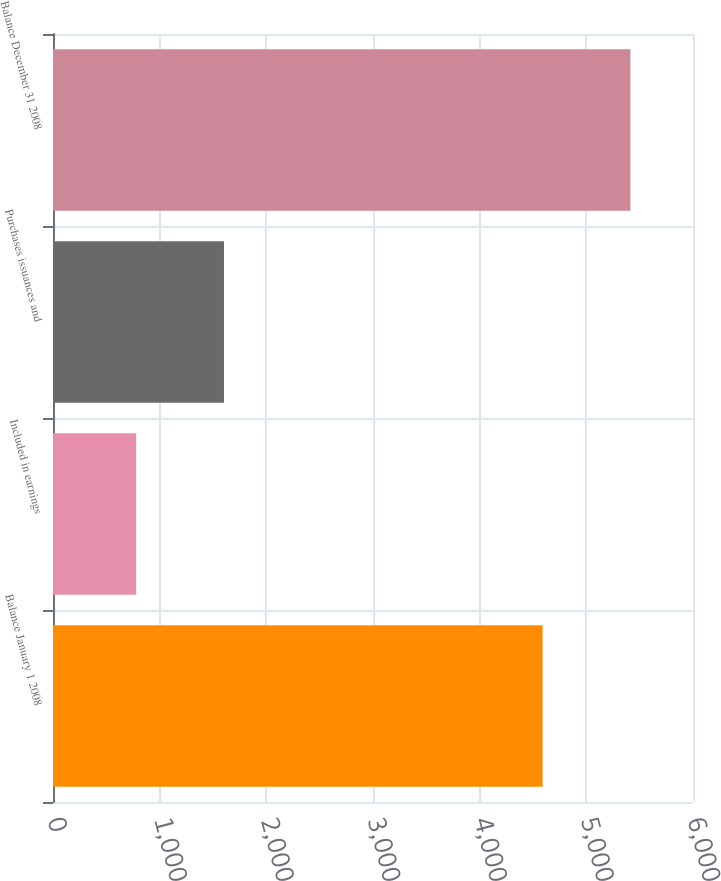<chart> <loc_0><loc_0><loc_500><loc_500><bar_chart><fcel>Balance January 1 2008<fcel>Included in earnings<fcel>Purchases issuances and<fcel>Balance December 31 2008<nl><fcel>4590<fcel>780<fcel>1603<fcel>5413<nl></chart> 